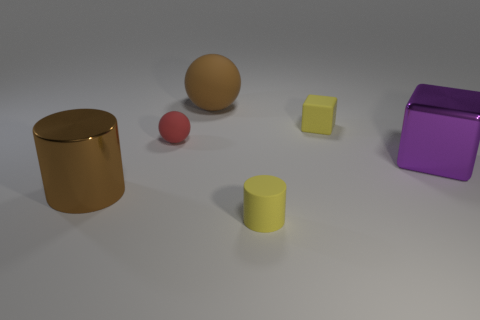What number of metal things are tiny yellow objects or big things?
Provide a succinct answer. 2. There is a big brown object to the left of the big matte thing; how many big purple metallic blocks are on the left side of it?
Offer a terse response. 0. There is a cylinder that is the same color as the small cube; what size is it?
Your answer should be very brief. Small. What number of objects are tiny cubes or tiny yellow matte things that are in front of the big brown metallic cylinder?
Ensure brevity in your answer.  2. Is there a purple block that has the same material as the tiny yellow cube?
Offer a very short reply. No. What number of small things are both to the right of the small red matte ball and in front of the small cube?
Your answer should be compact. 1. What is the material of the yellow object behind the small rubber cylinder?
Your answer should be compact. Rubber. The cylinder that is the same material as the tiny red sphere is what size?
Your response must be concise. Small. Are there any large brown spheres behind the big brown cylinder?
Your answer should be compact. Yes. What is the size of the brown rubber object that is the same shape as the small red matte thing?
Ensure brevity in your answer.  Large. 